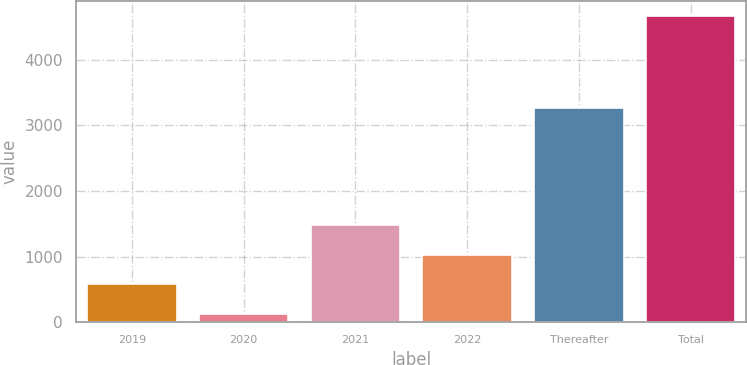Convert chart to OTSL. <chart><loc_0><loc_0><loc_500><loc_500><bar_chart><fcel>2019<fcel>2020<fcel>2021<fcel>2022<fcel>Thereafter<fcel>Total<nl><fcel>574.1<fcel>119<fcel>1484.3<fcel>1029.2<fcel>3261<fcel>4670<nl></chart> 